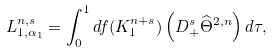Convert formula to latex. <formula><loc_0><loc_0><loc_500><loc_500>L ^ { n , s } _ { 1 , \alpha _ { 1 } } = \int _ { 0 } ^ { 1 } d f ( K _ { 1 } ^ { n + s } ) \left ( D _ { + } ^ { s } \widehat { \Theta } ^ { 2 , n } \right ) d \tau ,</formula> 